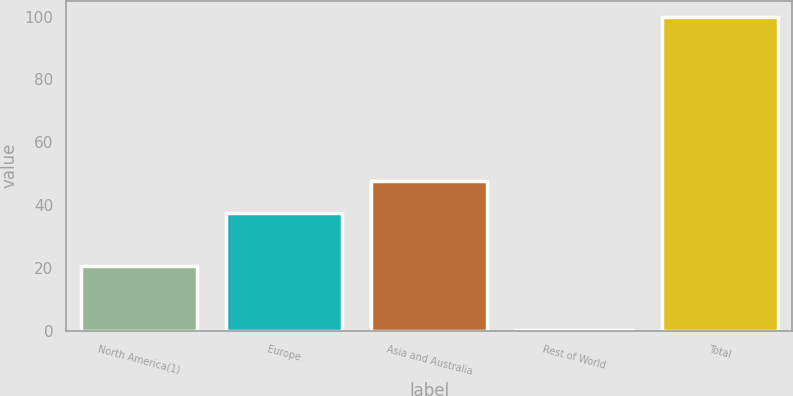Convert chart. <chart><loc_0><loc_0><loc_500><loc_500><bar_chart><fcel>North America(1)<fcel>Europe<fcel>Asia and Australia<fcel>Rest of World<fcel>Total<nl><fcel>20.6<fcel>37.6<fcel>47.57<fcel>0.3<fcel>100<nl></chart> 